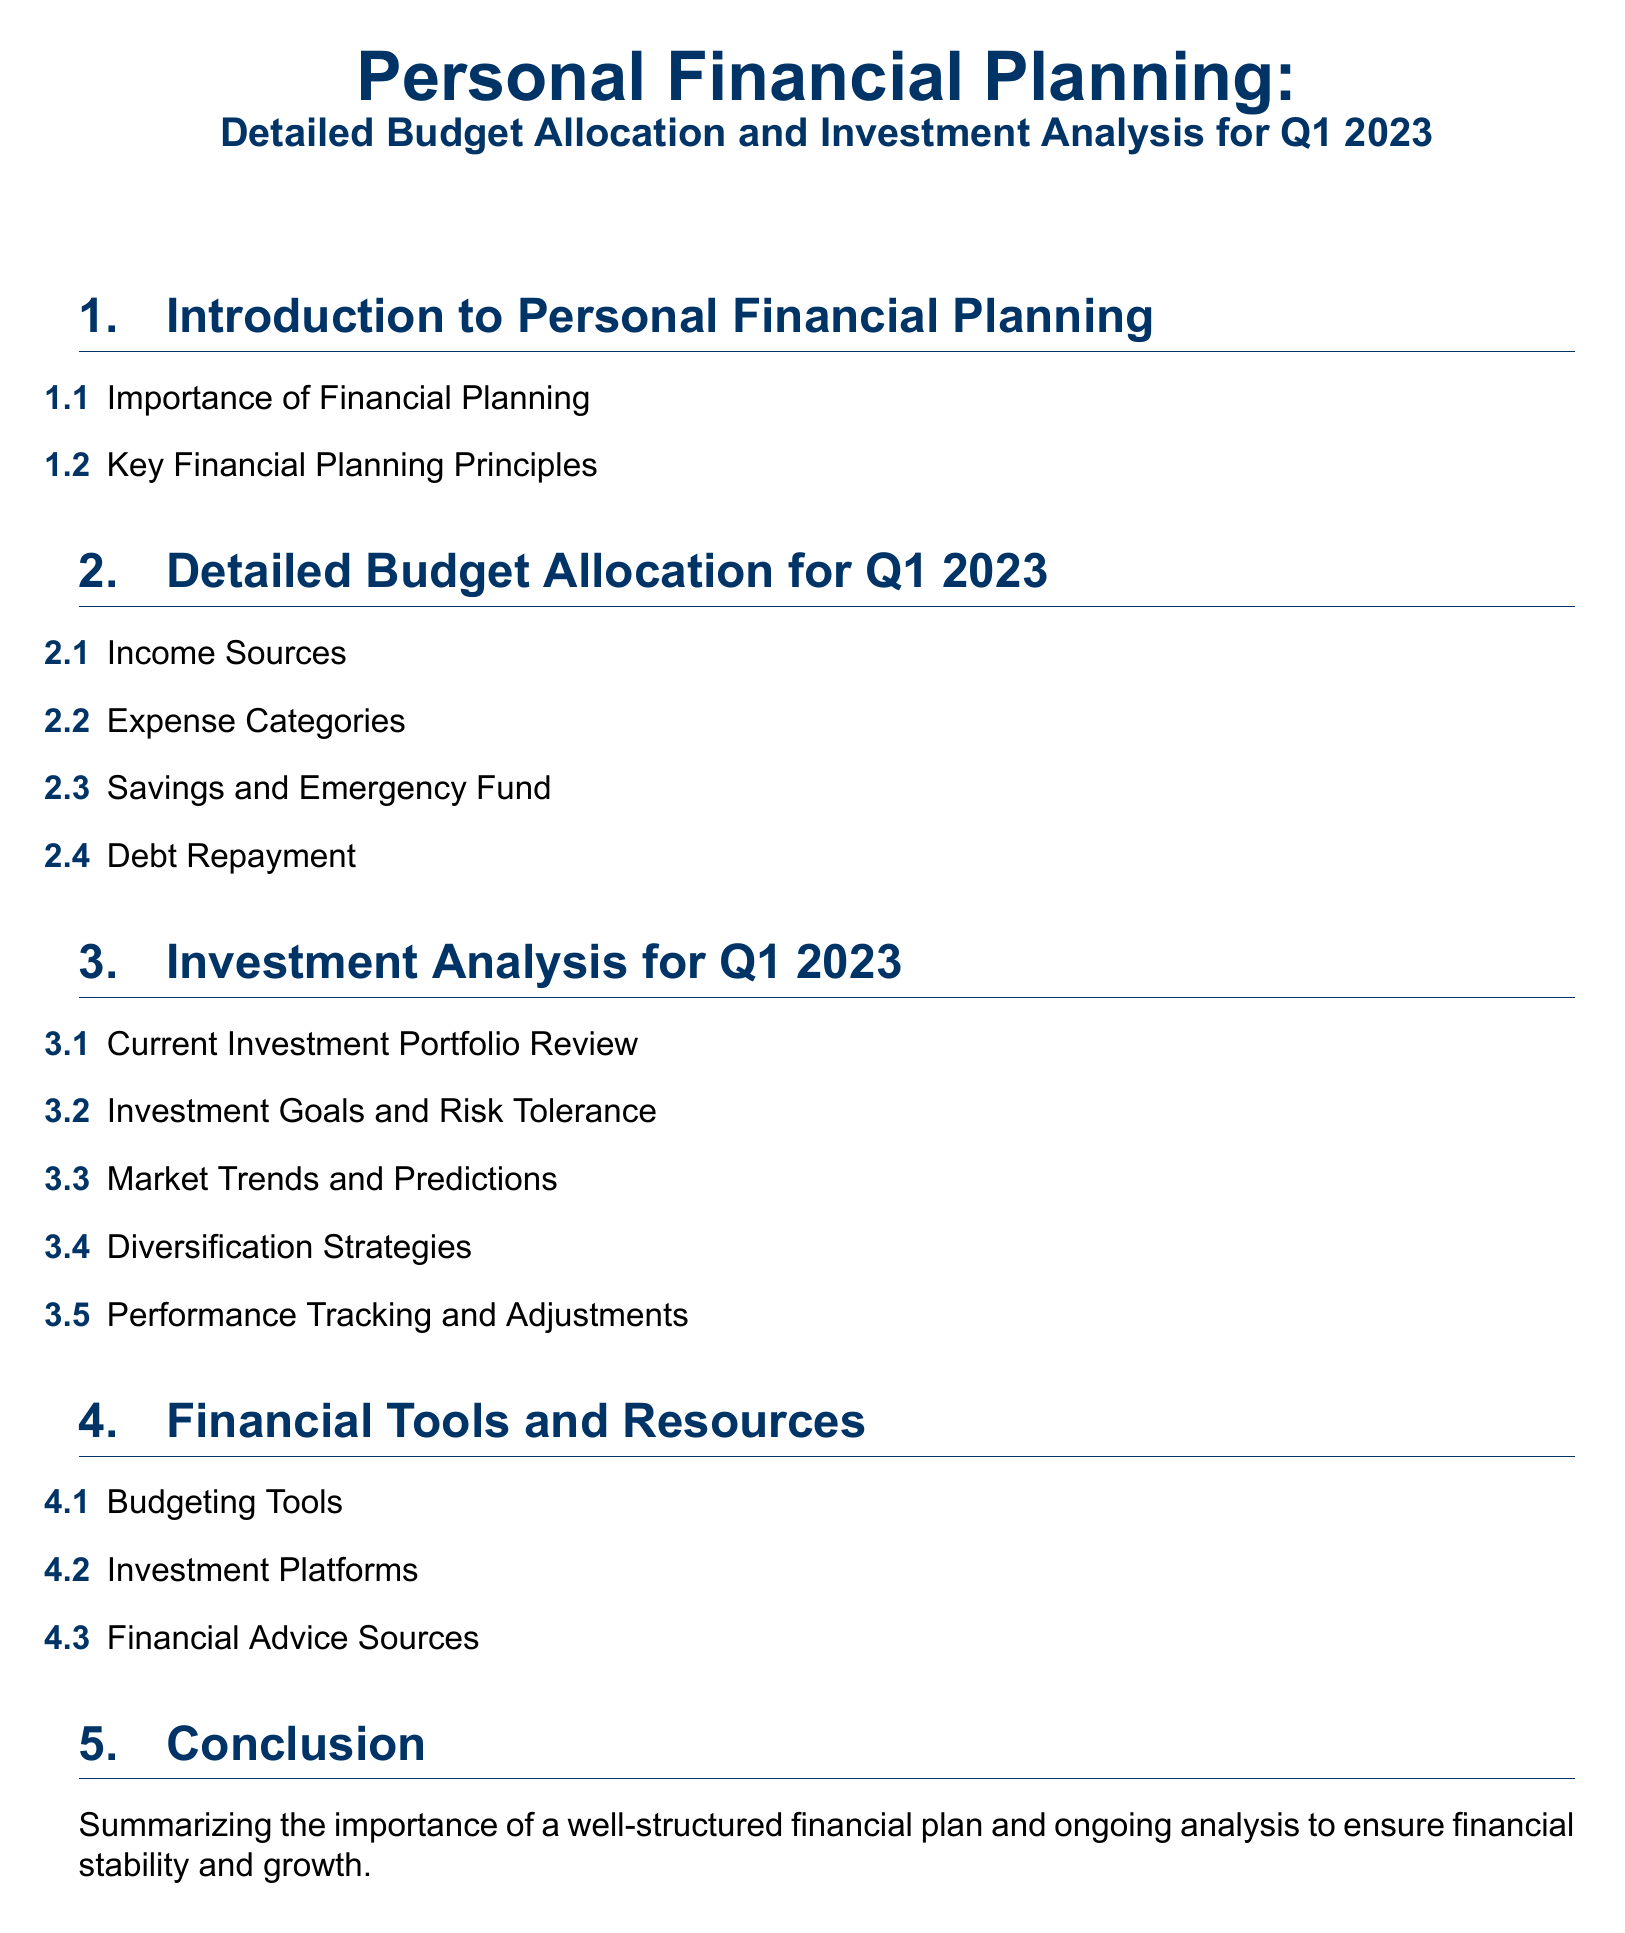What is the title of the document? The title of the document is presented at the top and encapsulates the subject matter.
Answer: Personal Financial Planning: Detailed Budget Allocation and Investment Analysis for Q1 2023 What section covers Debt Repayment? This information is found in the detailed budget allocation section of the document, indicating its importance in financial planning.
Answer: 2.4 How many subsections are in the Investment Analysis section? The number of subsections can be counted directly from the list provided in the document.
Answer: 5 What is emphasized in section 1 of the document? This section highlights the fundamental aspects of financial management important for planning stability.
Answer: Importance of Financial Planning What type of financial tools are listed? The tools are specifically categorized under budgeting and investment support in the document.
Answer: Budgeting Tools 